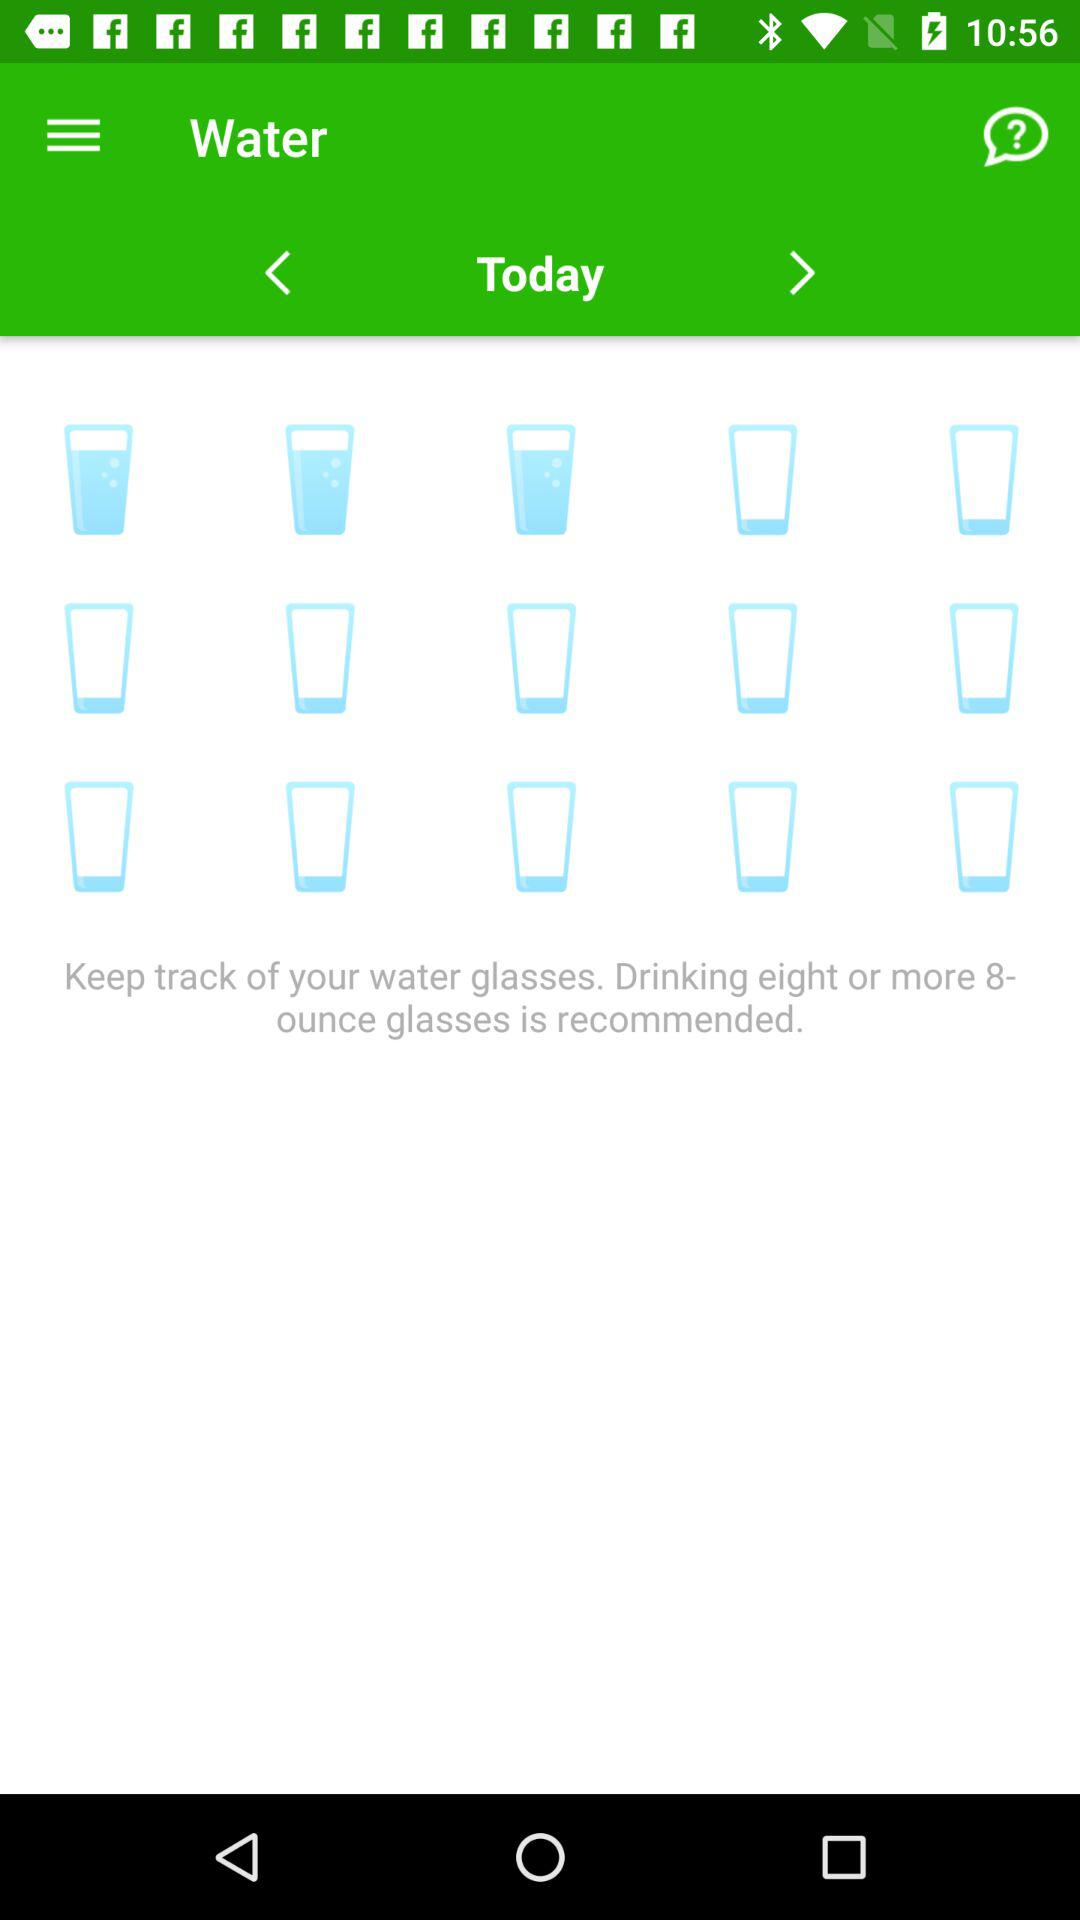How many ounce glasses should be recommended for drinking? The recommended quantity for drinking is eight or more 8-ounce glasses. 